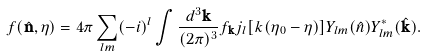Convert formula to latex. <formula><loc_0><loc_0><loc_500><loc_500>f ( \hat { \mathbf n } , \eta ) = 4 \pi \sum _ { l m } ( - i ) ^ { l } \int \frac { d ^ { 3 } { \mathbf k } } { ( 2 \pi ) ^ { 3 } } f _ { \mathbf k } j _ { l } [ k ( \eta _ { 0 } - \eta ) ] Y _ { l m } ( \hat { n } ) Y _ { l m } ^ { * } ( \hat { \mathbf k } ) .</formula> 